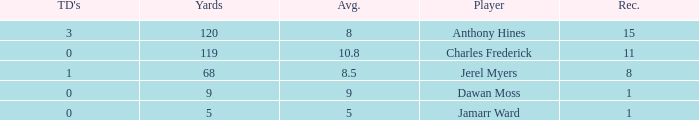What is the total Avg when TDs are 0 and Dawan Moss is a player? 0.0. 